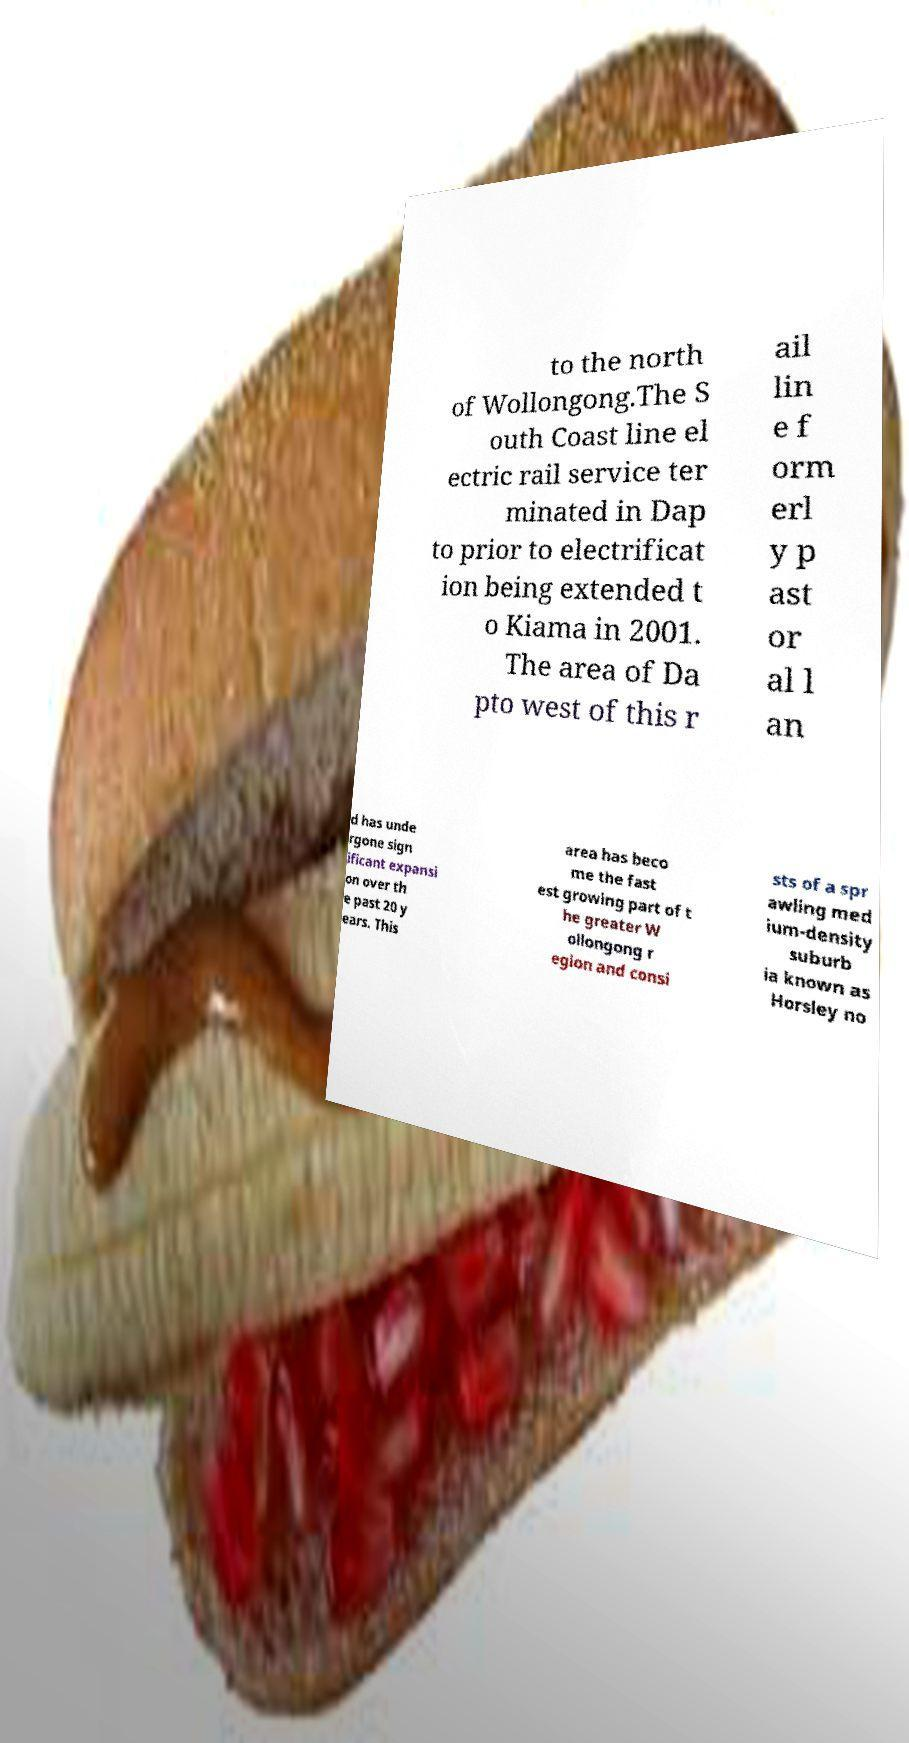Can you accurately transcribe the text from the provided image for me? to the north of Wollongong.The S outh Coast line el ectric rail service ter minated in Dap to prior to electrificat ion being extended t o Kiama in 2001. The area of Da pto west of this r ail lin e f orm erl y p ast or al l an d has unde rgone sign ificant expansi on over th e past 20 y ears. This area has beco me the fast est growing part of t he greater W ollongong r egion and consi sts of a spr awling med ium-density suburb ia known as Horsley no 